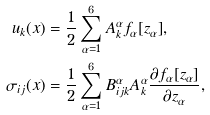<formula> <loc_0><loc_0><loc_500><loc_500>u _ { k } ( x ) & = \frac { 1 } { 2 } \sum _ { \alpha = 1 } ^ { 6 } { A _ { k } ^ { \alpha } f _ { \alpha } [ z _ { \alpha } ] } , \\ \sigma _ { i j } ( x ) & = \frac { 1 } { 2 } \sum _ { \alpha = 1 } ^ { 6 } { B _ { i j k } ^ { \alpha } A _ { k } ^ { \alpha } \frac { \partial f _ { \alpha } [ z _ { \alpha } ] } { \partial z _ { \alpha } } } ,</formula> 